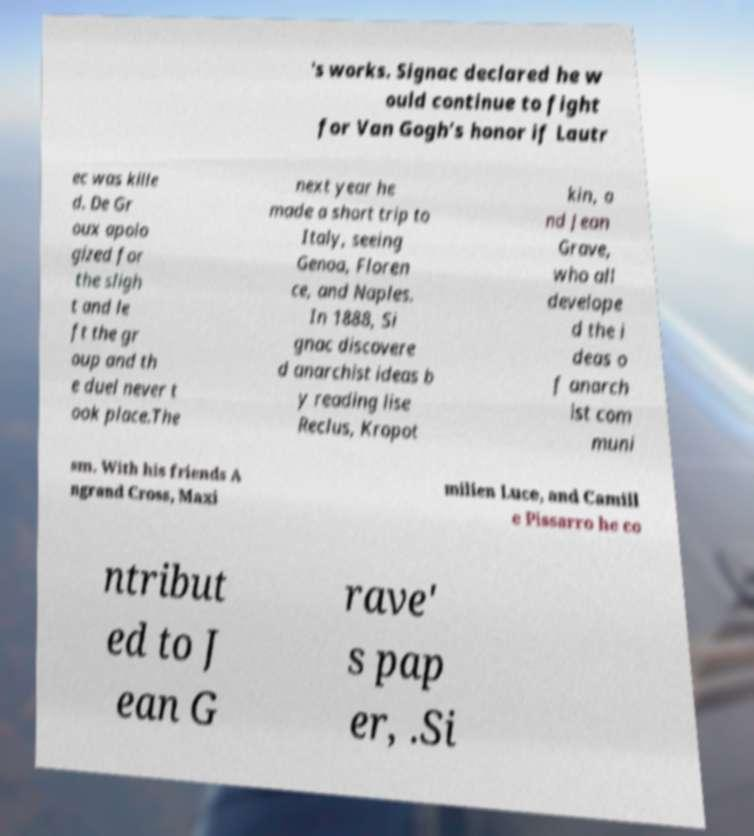Please read and relay the text visible in this image. What does it say? 's works. Signac declared he w ould continue to fight for Van Gogh’s honor if Lautr ec was kille d. De Gr oux apolo gized for the sligh t and le ft the gr oup and th e duel never t ook place.The next year he made a short trip to Italy, seeing Genoa, Floren ce, and Naples. In 1888, Si gnac discovere d anarchist ideas b y reading lise Reclus, Kropot kin, a nd Jean Grave, who all develope d the i deas o f anarch ist com muni sm. With his friends A ngrand Cross, Maxi milien Luce, and Camill e Pissarro he co ntribut ed to J ean G rave' s pap er, .Si 